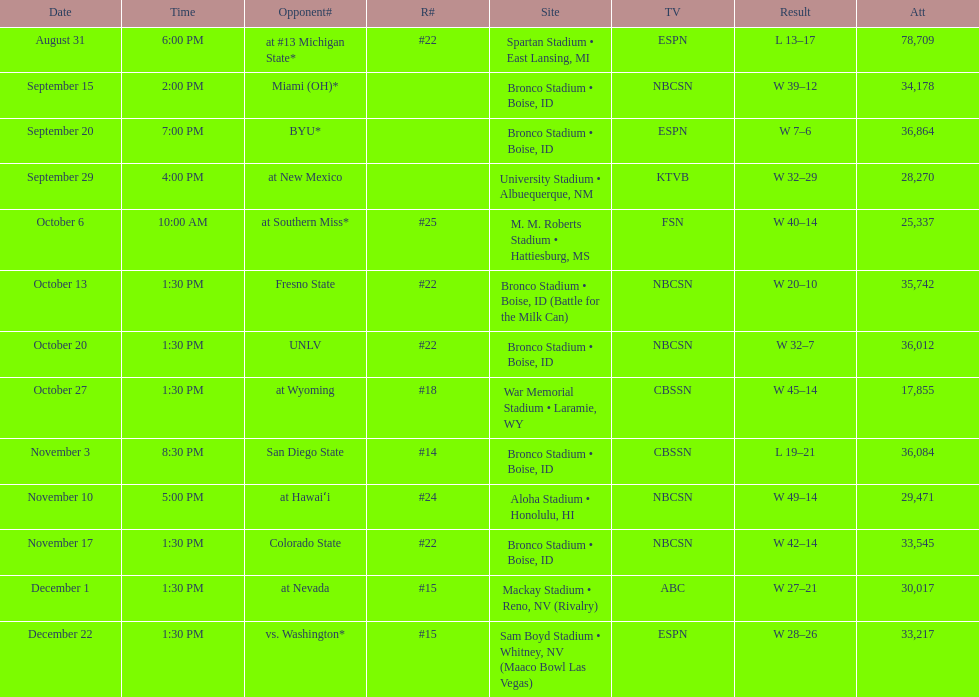What was there top ranked position of the season? #14. 